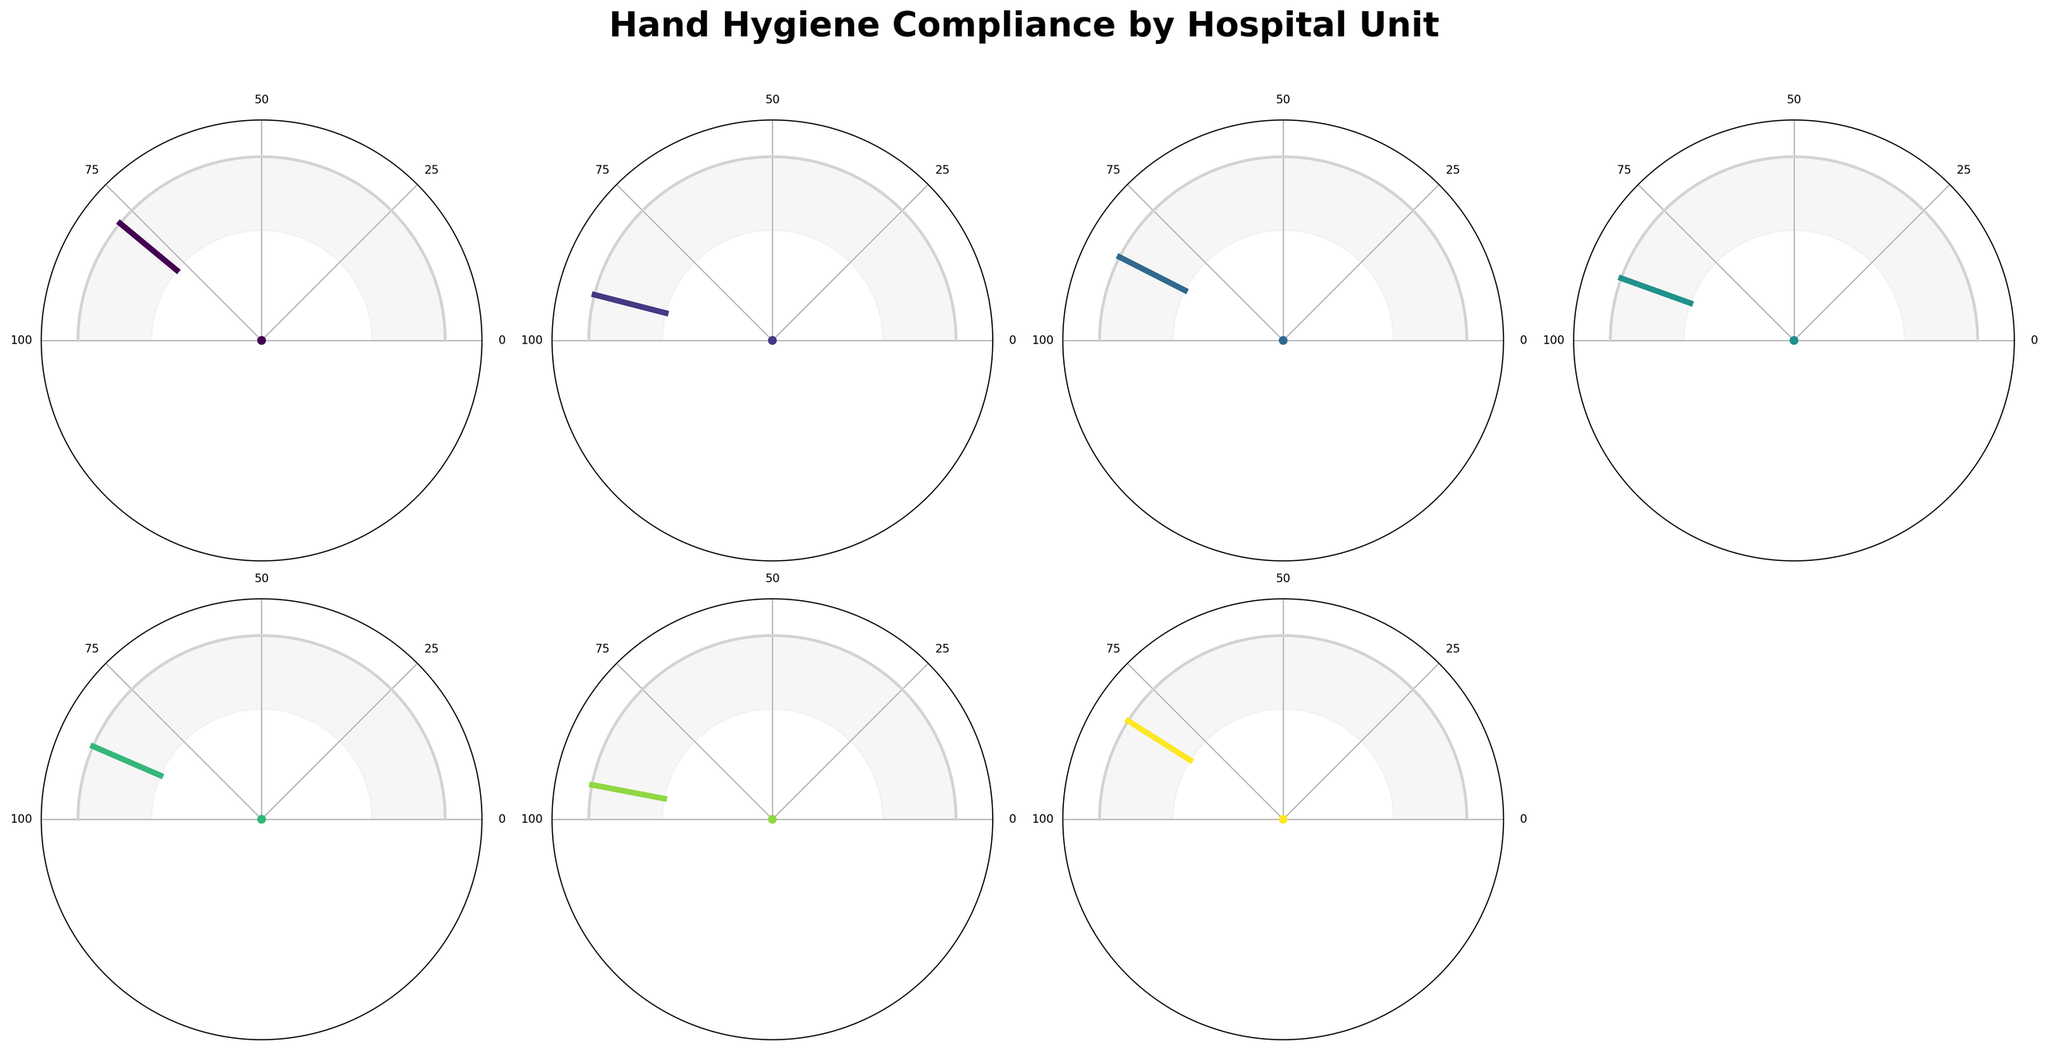What's the title of the figure? The title is displayed prominently at the top of the figure. By reading it, we can understand the subject of the figure.
Answer: Hand Hygiene Compliance by Hospital Unit Which hospital unit has the highest compliance percentage? Look at the values next to each gauge and identify the highest one. Labor and Delivery has the highest compliance percentage next to its gauge at 94%.
Answer: Labor and Delivery What's the compliance percentage for the Emergency Department? The percentage is displayed directly next to the gauge for the Emergency Department. It shows 78%.
Answer: 78% How does the compliance level of Neurology compare to General Surgery? The compliance percentages for Neurology and General Surgery are shown next to their respective gauges. Neurology is 82% and General Surgery is 85%, so General Surgery has a higher compliance level.
Answer: General Surgery is higher What's the average compliance percentage across all units? Sum all the compliance percentages and divide by the number of units. (78 + 92 + 85 + 89 + 87 + 94 + 82) / 7 = 607 / 7 = 86.71
Answer: 86.71 Which unit has a compliance level closest to 90%? Compare all the given compliance percentages to 90%. The Pediatrics unit which has a compliance percentage of 89%, is the closest to 90%.
Answer: Pediatrics If the acceptable compliance threshold is 85%, which units fall below this threshold? Identify units with compliance percentages less than 85%. Emergency Department (78%) and Neurology (82%) fall below this threshold.
Answer: Emergency Department, Neurology What is the range of compliance percentages in the figure? Identify the lowest and highest compliance percentages from the data. The lowest is 78% (Emergency Department), and the highest is 94% (Labor and Delivery). Hence the range is 94% - 78% = 16%.
Answer: 16% How much higher is the compliance percentage in the Intensive Care Unit compared to the Emergency Department? Subtract the compliance percentage of the Emergency Department from that of the Intensive Care Unit. 92% (Intensive Care Unit) - 78% (Emergency Department) = 14%.
Answer: 14 